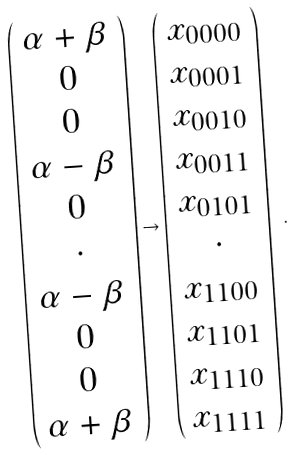Convert formula to latex. <formula><loc_0><loc_0><loc_500><loc_500>\left ( \begin{array} { c } \alpha + \beta \\ 0 \\ 0 \\ \alpha - \beta \\ 0 \\ \cdot \\ \alpha - \beta \\ 0 \\ 0 \\ \alpha + \beta \\ \end{array} \right ) \rightarrow \left ( \begin{array} { c } x _ { 0 0 0 0 } \\ x _ { 0 0 0 1 } \\ x _ { 0 0 1 0 } \\ x _ { 0 0 1 1 } \\ x _ { 0 1 0 1 } \\ \cdot \\ x _ { 1 1 0 0 } \\ x _ { 1 1 0 1 } \\ x _ { 1 1 1 0 } \\ x _ { 1 1 1 1 } \end{array} \right ) \ .</formula> 